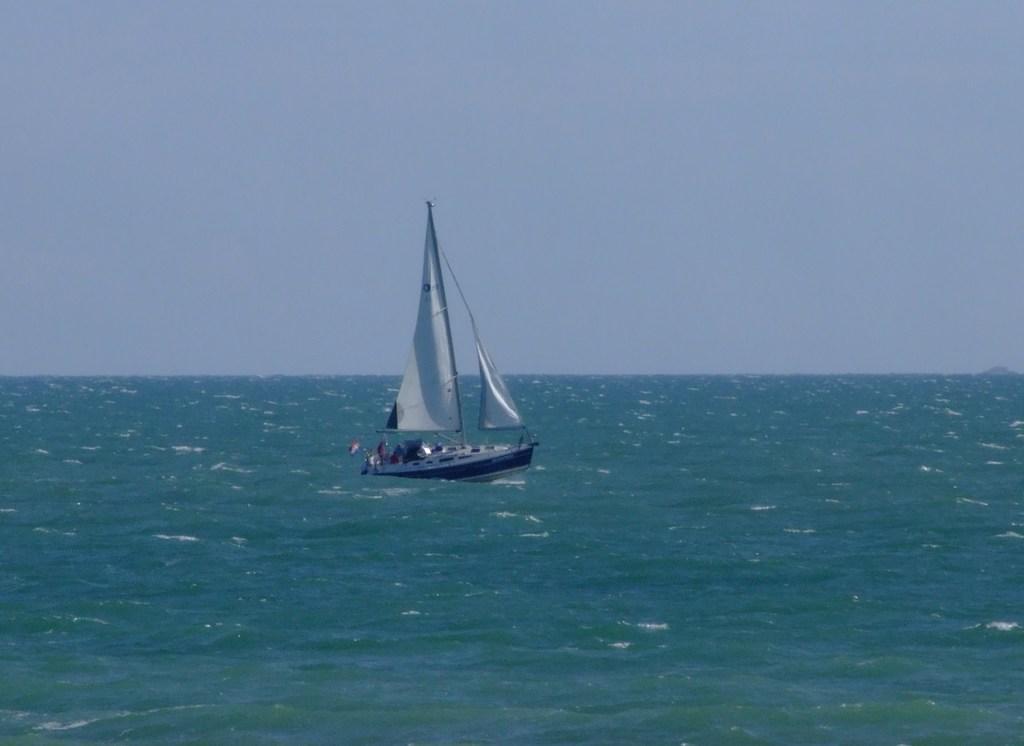How would you summarize this image in a sentence or two? This image is taken outdoors. At the top of the image there is the sky. At the bottom of the image there is a sea. In the middle of the image there is a boat on the sea. 